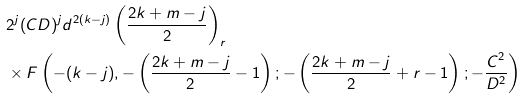<formula> <loc_0><loc_0><loc_500><loc_500>& 2 ^ { j } ( C D ) ^ { j } d ^ { 2 ( k - j ) } \left ( \frac { 2 k + m - j } 2 \right ) _ { r } \\ & \times F \left ( - ( k - j ) , - \left ( \frac { 2 k + m - j } 2 - 1 \right ) ; - \left ( \frac { 2 k + m - j } 2 + r - 1 \right ) ; - \frac { C ^ { 2 } } { D ^ { 2 } } \right )</formula> 